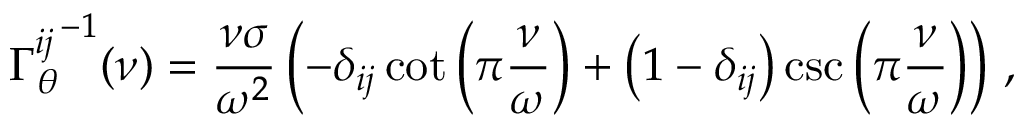<formula> <loc_0><loc_0><loc_500><loc_500>{ \Gamma _ { \theta } ^ { i j } } ^ { - 1 } ( \nu ) = \frac { \nu \sigma } { \omega ^ { 2 } } \left ( - \delta _ { i j } \cot \left ( \pi \frac { \nu } { \omega } \right ) + \left ( 1 - \delta _ { i j } \right ) \csc \left ( \pi \frac { \nu } { \omega } \right ) \right ) \, ,</formula> 